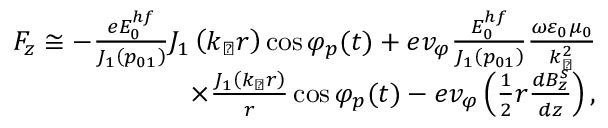Convert formula to latex. <formula><loc_0><loc_0><loc_500><loc_500>\begin{array} { r } { F _ { z } \cong - \frac { e E _ { 0 } ^ { h f } } { J _ { 1 } \left ( p _ { 0 1 } \right ) } J _ { 1 } \left ( k _ { \perp } r \right ) \cos \varphi _ { p } ( t ) + e v _ { \varphi } \frac { E _ { 0 } ^ { h f } } { J _ { 1 } \left ( p _ { 0 1 } \right ) } \frac { \omega \varepsilon _ { 0 } \mu _ { 0 } } { k _ { \perp } ^ { 2 } } } \\ { \times \frac { J _ { 1 } \left ( k _ { \perp } r \right ) } { r } \cos \varphi _ { p } ( t ) - e v _ { \varphi } \left ( \frac { 1 } { 2 } r \frac { d B _ { z } ^ { s } } { d z } \right ) , } \end{array}</formula> 